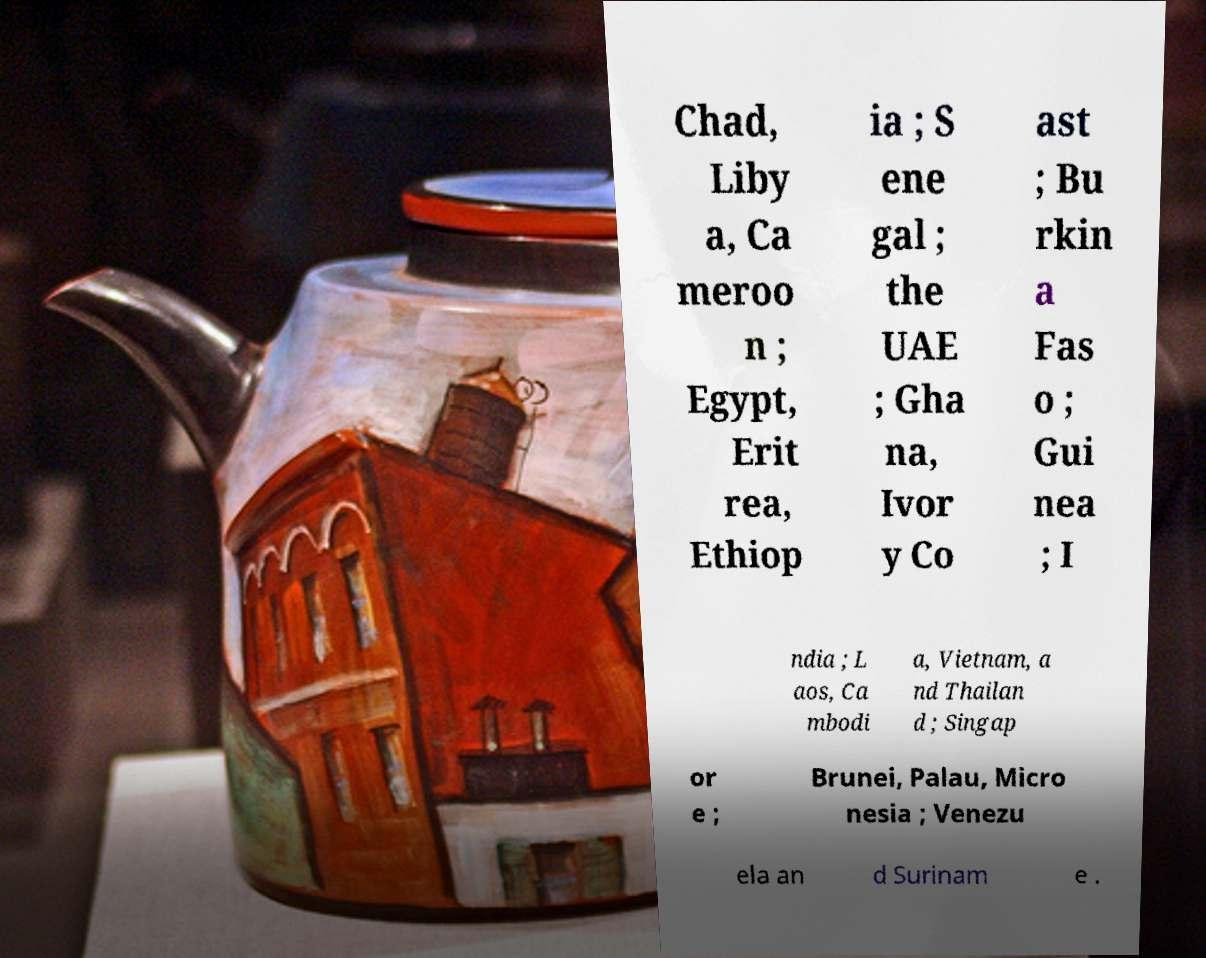What messages or text are displayed in this image? I need them in a readable, typed format. Chad, Liby a, Ca meroo n ; Egypt, Erit rea, Ethiop ia ; S ene gal ; the UAE ; Gha na, Ivor y Co ast ; Bu rkin a Fas o ; Gui nea ; I ndia ; L aos, Ca mbodi a, Vietnam, a nd Thailan d ; Singap or e ; Brunei, Palau, Micro nesia ; Venezu ela an d Surinam e . 